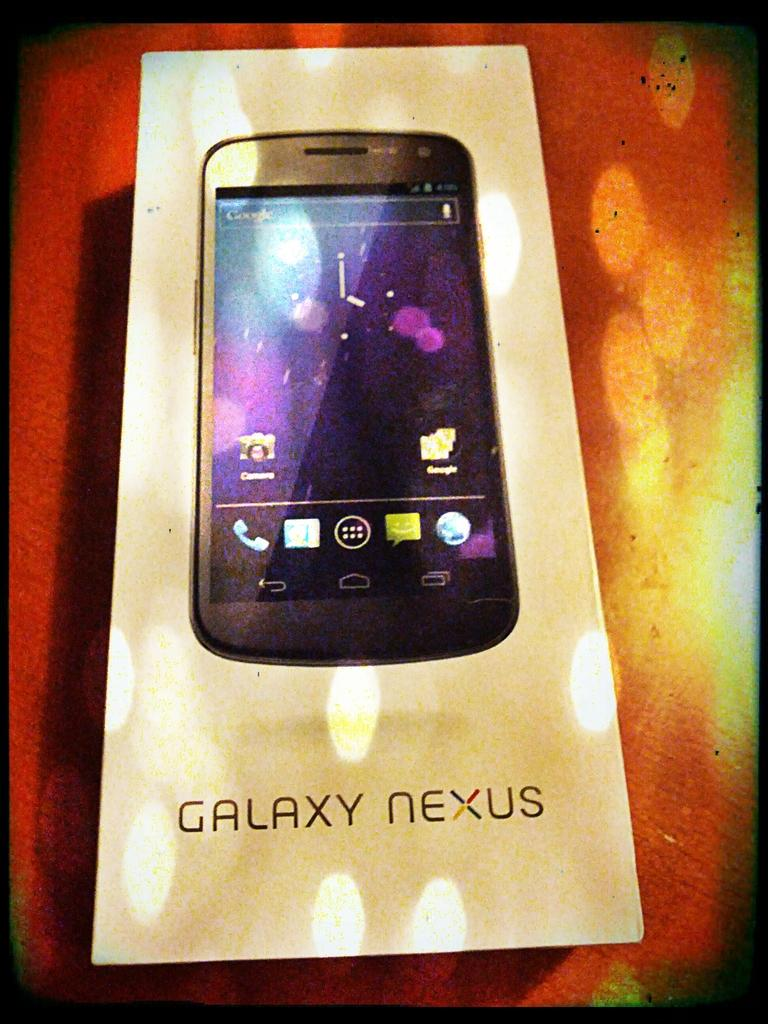What is the main subject of the image? The main subject of the image is a mobile box. What color is the mobile box? The mobile box is white in color. What is written on the mobile box? The name "Galaxy Nexus" is written on the mobile box. What is the background or surface on which the mobile box is placed? The mobile box is on a red and yellow color surface. Who is the owner of the mobile box in the image? The image does not provide information about the owner of the mobile box. Can you give an example of a similar mobile box in the image? There is no other mobile box present in the image to provide an example. 